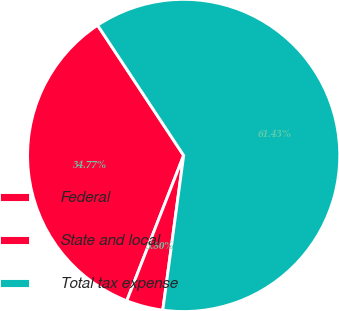Convert chart to OTSL. <chart><loc_0><loc_0><loc_500><loc_500><pie_chart><fcel>Federal<fcel>State and local<fcel>Total tax expense<nl><fcel>34.77%<fcel>3.8%<fcel>61.43%<nl></chart> 